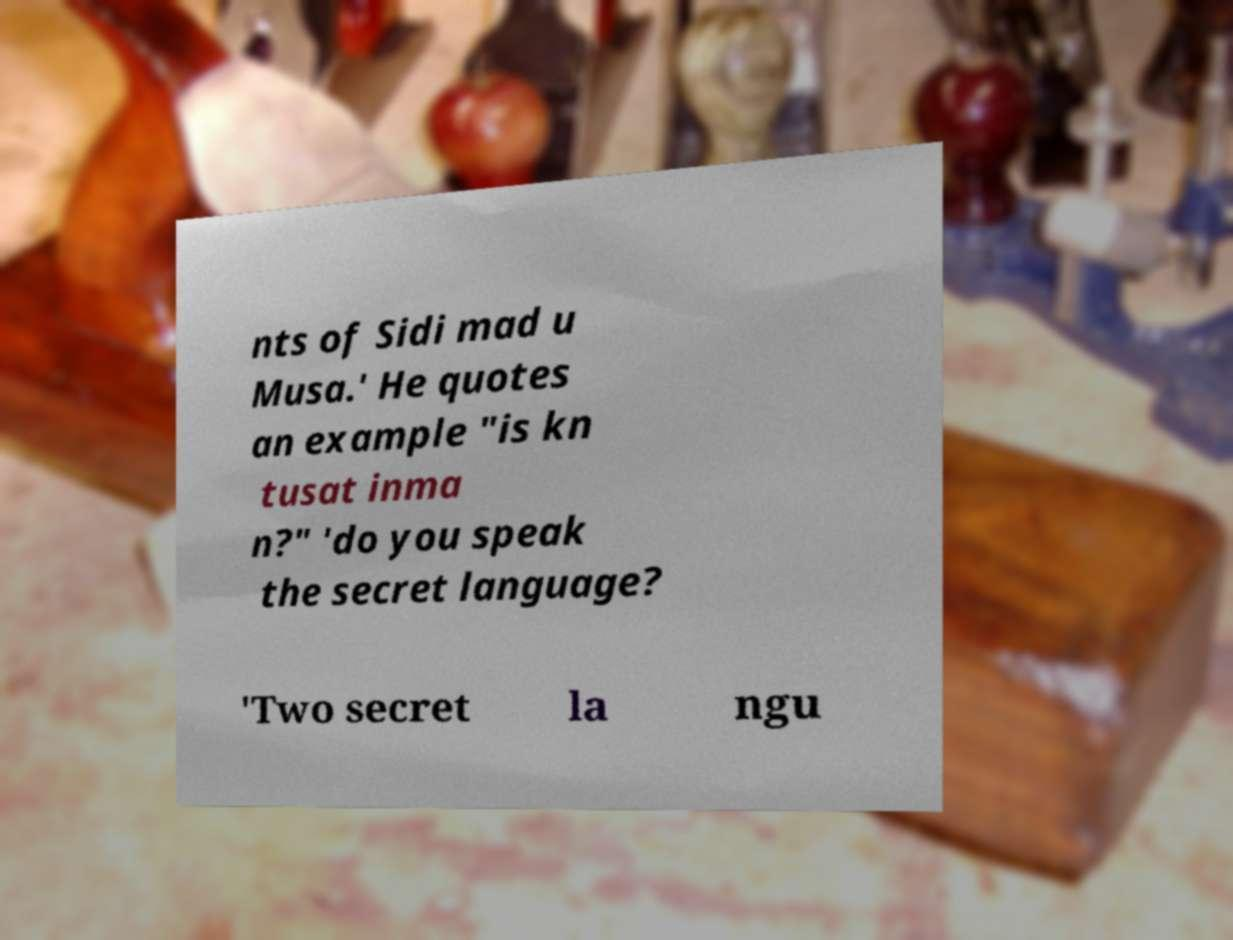I need the written content from this picture converted into text. Can you do that? nts of Sidi mad u Musa.' He quotes an example "is kn tusat inma n?" 'do you speak the secret language? 'Two secret la ngu 